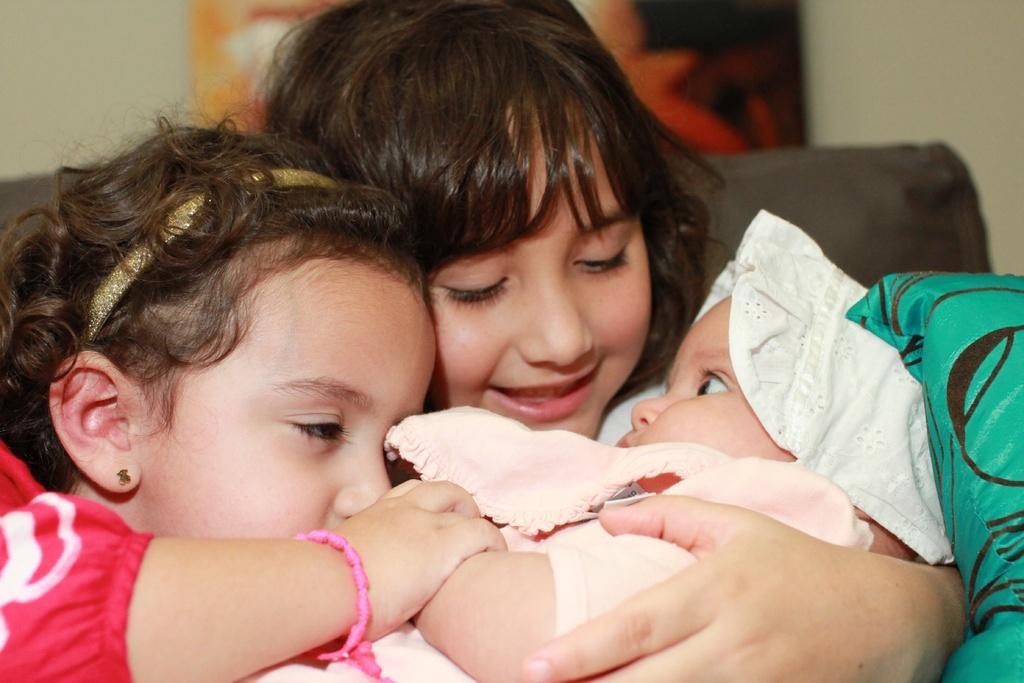Please provide a concise description of this image. In this image I can see 2 children holding a baby. The background is blurred. 